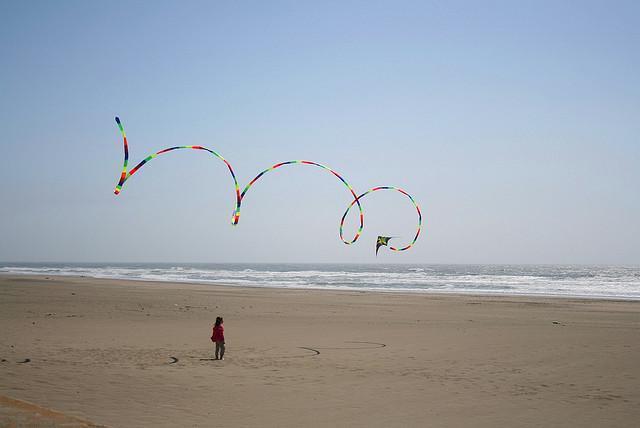How many people are standing on the beach?
Give a very brief answer. 1. 